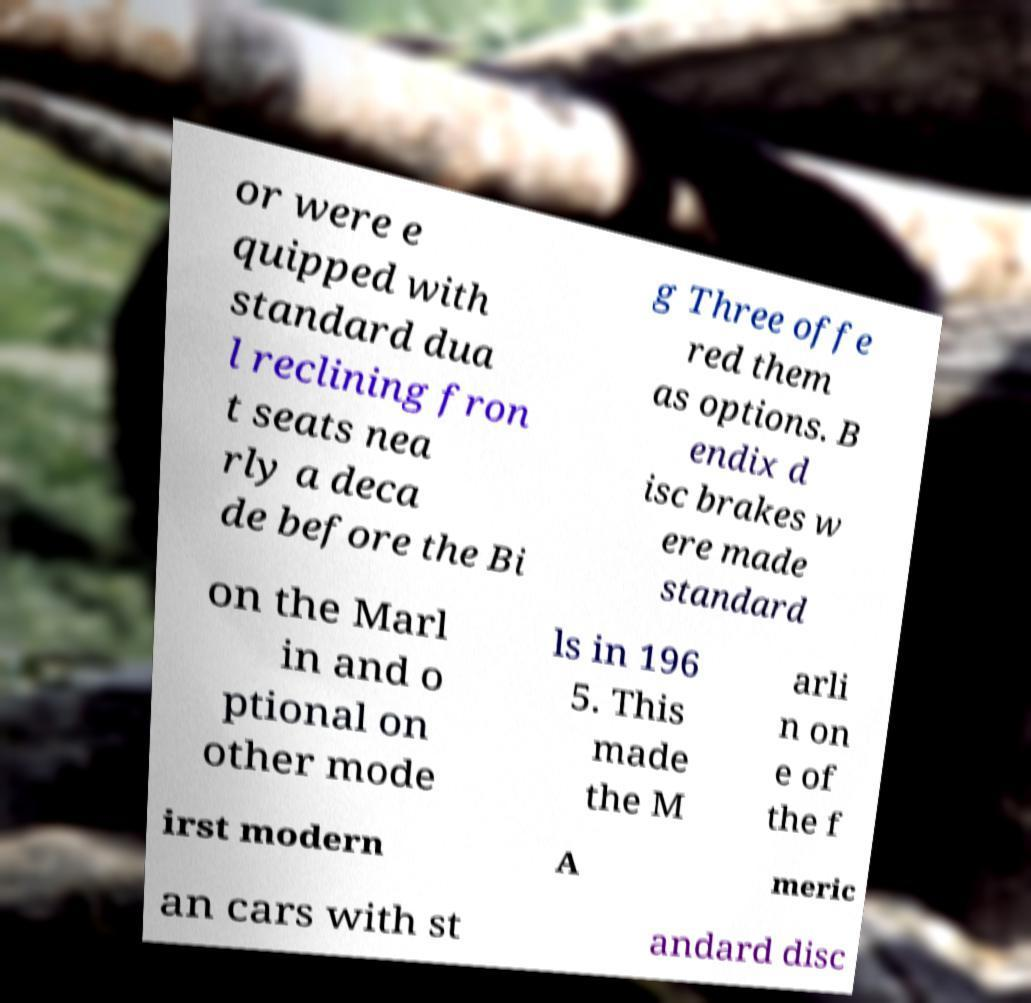Could you extract and type out the text from this image? or were e quipped with standard dua l reclining fron t seats nea rly a deca de before the Bi g Three offe red them as options. B endix d isc brakes w ere made standard on the Marl in and o ptional on other mode ls in 196 5. This made the M arli n on e of the f irst modern A meric an cars with st andard disc 